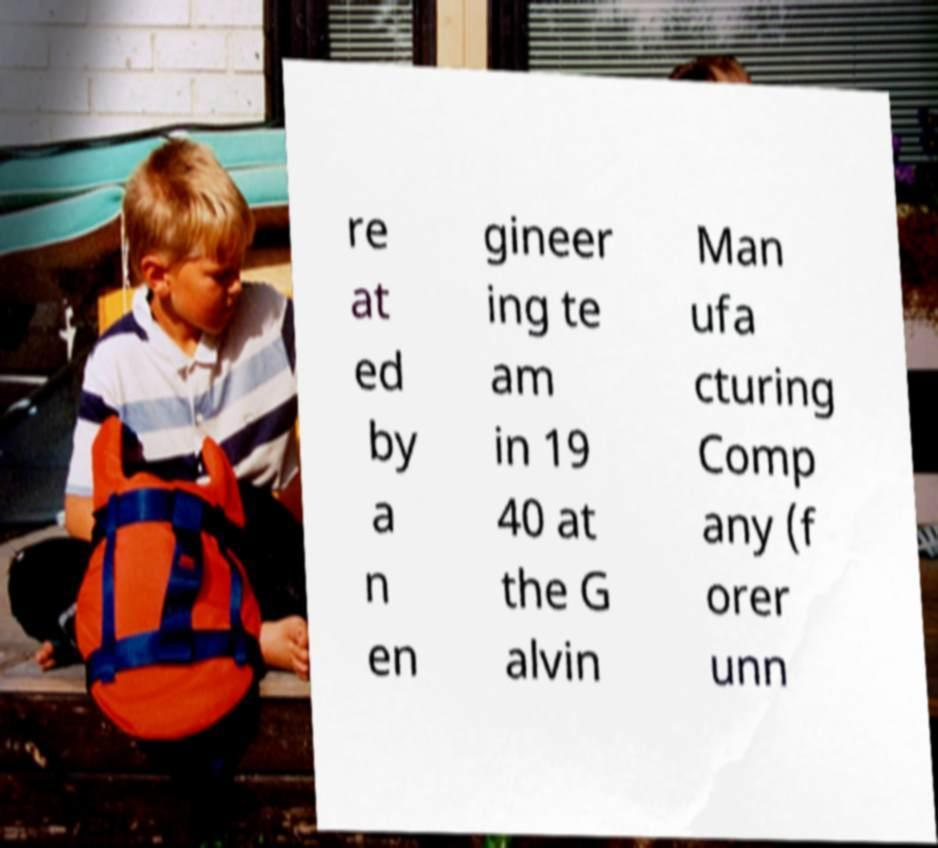What messages or text are displayed in this image? I need them in a readable, typed format. re at ed by a n en gineer ing te am in 19 40 at the G alvin Man ufa cturing Comp any (f orer unn 